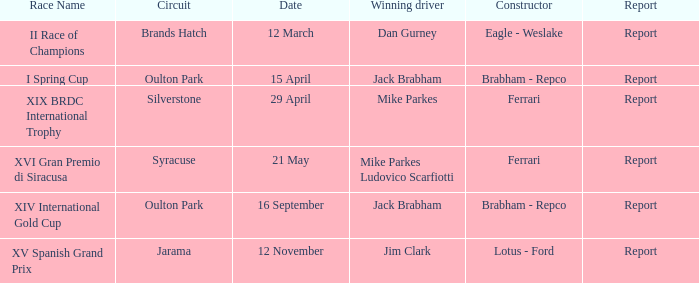What is the circuit occurring on april 15? Oulton Park. 